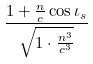<formula> <loc_0><loc_0><loc_500><loc_500>\frac { 1 + \frac { n } { c } \cos \iota _ { s } } { \sqrt { 1 \cdot \frac { n ^ { 3 } } { c ^ { 3 } } } }</formula> 